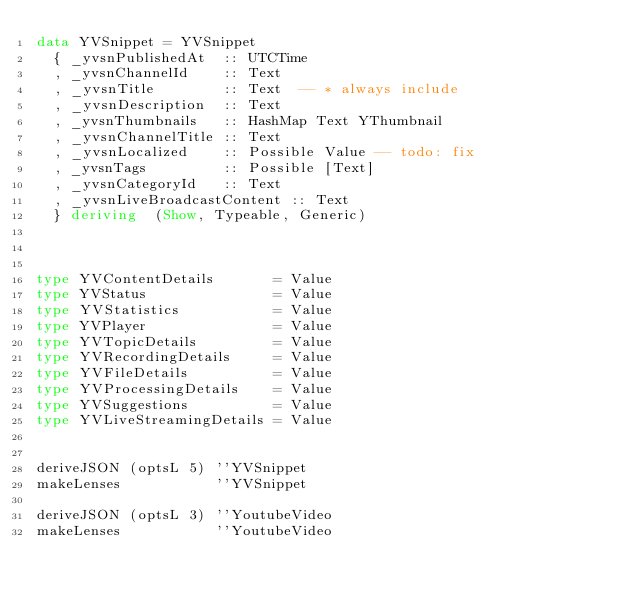<code> <loc_0><loc_0><loc_500><loc_500><_Haskell_>data YVSnippet = YVSnippet
  { _yvsnPublishedAt  :: UTCTime
  , _yvsnChannelId    :: Text
  , _yvsnTitle        :: Text  -- * always include
  , _yvsnDescription  :: Text
  , _yvsnThumbnails   :: HashMap Text YThumbnail
  , _yvsnChannelTitle :: Text
  , _yvsnLocalized    :: Possible Value -- todo: fix
  , _yvsnTags         :: Possible [Text]
  , _yvsnCategoryId   :: Text
  , _yvsnLiveBroadcastContent :: Text
  } deriving  (Show, Typeable, Generic)



type YVContentDetails       = Value
type YVStatus               = Value
type YVStatistics           = Value
type YVPlayer               = Value
type YVTopicDetails         = Value
type YVRecordingDetails     = Value
type YVFileDetails          = Value
type YVProcessingDetails    = Value
type YVSuggestions          = Value
type YVLiveStreamingDetails = Value


deriveJSON (optsL 5) ''YVSnippet
makeLenses           ''YVSnippet

deriveJSON (optsL 3) ''YoutubeVideo
makeLenses           ''YoutubeVideo
</code> 